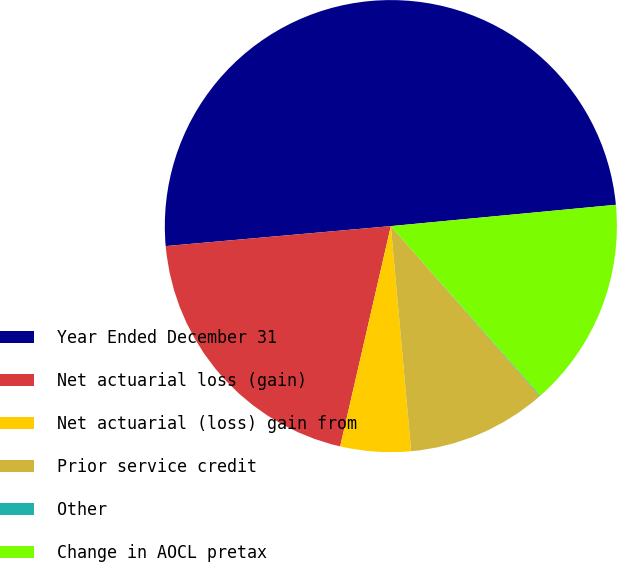Convert chart. <chart><loc_0><loc_0><loc_500><loc_500><pie_chart><fcel>Year Ended December 31<fcel>Net actuarial loss (gain)<fcel>Net actuarial (loss) gain from<fcel>Prior service credit<fcel>Other<fcel>Change in AOCL pretax<nl><fcel>49.9%<fcel>19.99%<fcel>5.03%<fcel>10.02%<fcel>0.05%<fcel>15.0%<nl></chart> 